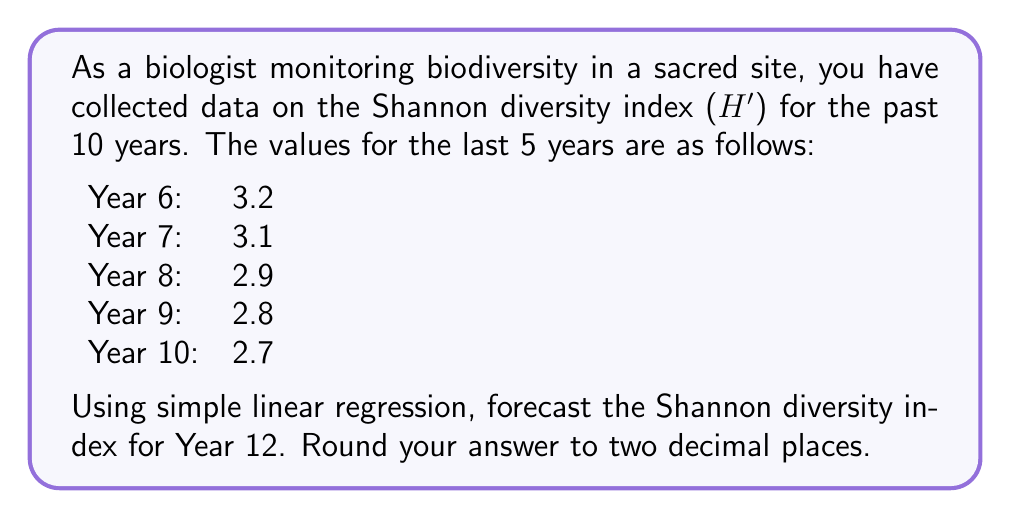Can you solve this math problem? To forecast the Shannon diversity index for Year 12 using simple linear regression, we'll follow these steps:

1. Assign x values to the years (1-5 for simplicity) and y values to the corresponding H' values.

2. Calculate the means of x and y:
   $\bar{x} = \frac{1 + 2 + 3 + 4 + 5}{5} = 3$
   $\bar{y} = \frac{3.2 + 3.1 + 2.9 + 2.8 + 2.7}{5} = 2.94$

3. Calculate the slope (b) of the regression line:
   $b = \frac{\sum(x_i - \bar{x})(y_i - \bar{y})}{\sum(x_i - \bar{x})^2}$

   $\sum(x_i - \bar{x})(y_i - \bar{y}) = (1-3)(3.2-2.94) + (2-3)(3.1-2.94) + (3-3)(2.9-2.94) + (4-3)(2.8-2.94) + (5-3)(2.7-2.94) = -0.5$

   $\sum(x_i - \bar{x})^2 = (1-3)^2 + (2-3)^2 + (3-3)^2 + (4-3)^2 + (5-3)^2 = 10$

   $b = \frac{-0.5}{10} = -0.05$

4. Calculate the y-intercept (a):
   $a = \bar{y} - b\bar{x} = 2.94 - (-0.05 * 3) = 3.09$

5. The regression line equation is:
   $y = a + bx = 3.09 - 0.05x$

6. To forecast Year 12, we use x = 7 (as Year 10 corresponds to x = 5):
   $y = 3.09 - 0.05(7) = 3.09 - 0.35 = 2.74$

Therefore, the forecasted Shannon diversity index for Year 12 is 2.74.
Answer: 2.74 